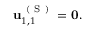Convert formula to latex. <formula><loc_0><loc_0><loc_500><loc_500>\begin{array} { r } { u _ { 1 , 1 } ^ { ( S ) } = 0 . } \end{array}</formula> 